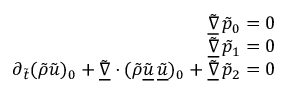<formula> <loc_0><loc_0><loc_500><loc_500>\begin{array} { r } { \underline { { \tilde { \nabla } } } \, \tilde { p } _ { 0 } = 0 } \\ { \underline { { \tilde { \nabla } } } \, \tilde { p } _ { 1 } = 0 } \\ { \partial _ { \tilde { t } } ( \tilde { \rho } \tilde { u } ) _ { 0 } + \underline { { \tilde { \nabla } } } \cdot ( \tilde { \rho } \underline { { \tilde { u } } } \, \underline { { \tilde { u } } } ) _ { 0 } + \underline { { \tilde { \nabla } } } \, \tilde { p } _ { 2 } = 0 } \end{array}</formula> 